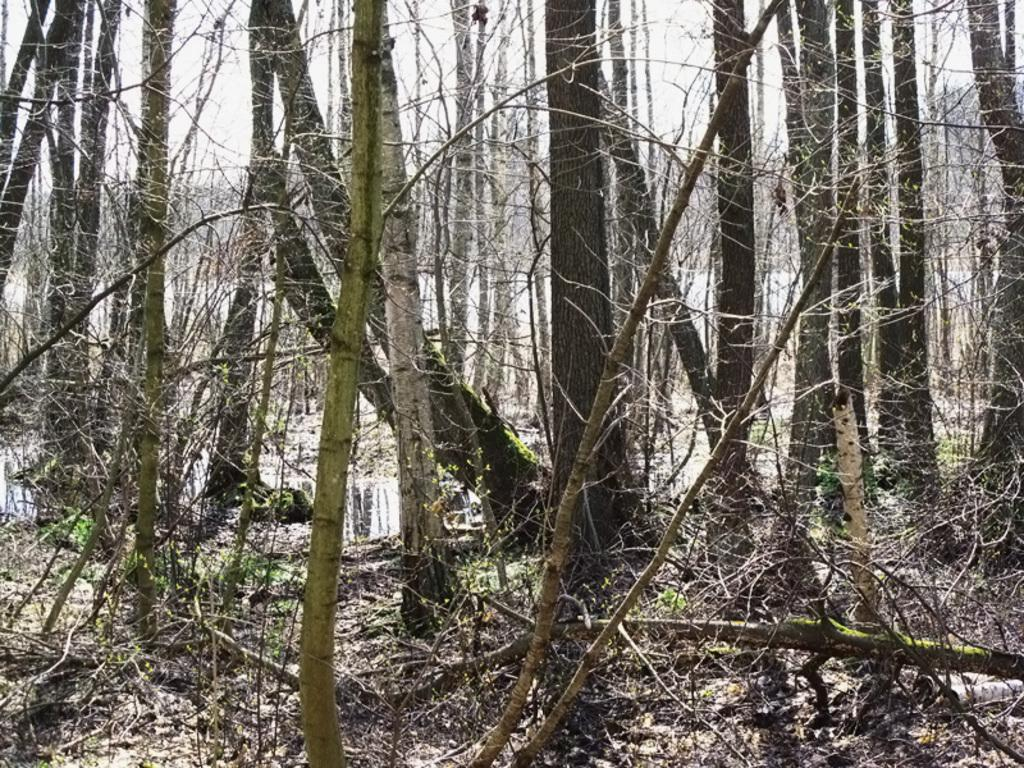What type of environment is depicted in the image? The image appears to be taken in a forest. What can be seen in the foreground of the image? There are many trees in the front of the image. What type of vegetation can be seen at the bottom of the image? Dried leaves and stems are visible at the bottom of the image. What type of basketball invention can be seen in the image? There is no basketball or invention present in the image; it depicts a forest scene. 